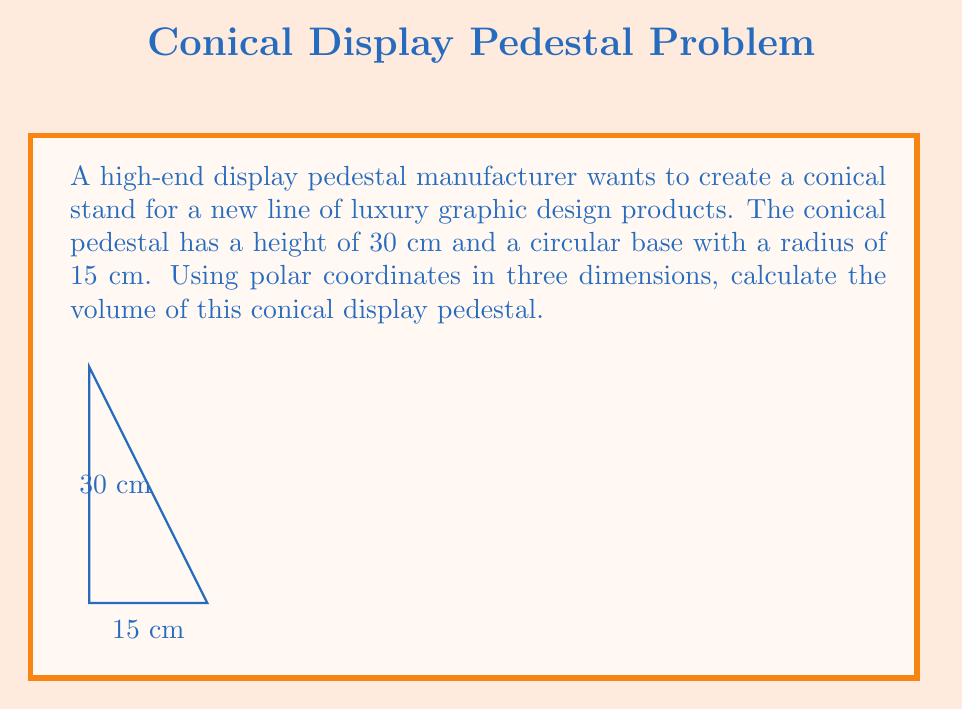Show me your answer to this math problem. To compute the volume of the conical display pedestal using polar coordinates in three dimensions, we'll follow these steps:

1) In polar coordinates, we can represent the cone as:
   $$r = R\frac{h-z}{h}$$
   where $R$ is the base radius, $h$ is the height, and $z$ is the vertical coordinate.

2) The volume formula in polar coordinates is:
   $$V = \int_0^h \int_0^{2\pi} \int_0^{r(z)} \rho \, d\rho \, d\theta \, dz$$

3) Substituting our cone equation:
   $$V = \int_0^h \int_0^{2\pi} \int_0^{R\frac{h-z}{h}} \rho \, d\rho \, d\theta \, dz$$

4) Evaluate the innermost integral:
   $$V = \int_0^h \int_0^{2\pi} \left[\frac{1}{2}\rho^2\right]_0^{R\frac{h-z}{h}} \, d\theta \, dz$$
   $$V = \int_0^h \int_0^{2\pi} \frac{1}{2}\left(R\frac{h-z}{h}\right)^2 \, d\theta \, dz$$

5) Evaluate the $\theta$ integral:
   $$V = \int_0^h 2\pi \cdot \frac{1}{2}\left(R\frac{h-z}{h}\right)^2 \, dz$$
   $$V = \pi R^2 \int_0^h \left(\frac{h-z}{h}\right)^2 \, dz$$

6) Evaluate the final integral:
   $$V = \pi R^2 \left[-\frac{1}{3h^2}(h-z)^3\right]_0^h$$
   $$V = \pi R^2 \left(-\frac{1}{3h^2}(0)^3 + \frac{1}{3h^2}h^3\right)$$
   $$V = \frac{1}{3}\pi R^2 h$$

7) Now, substitute the given values: $R = 15$ cm, $h = 30$ cm
   $$V = \frac{1}{3} \pi (15\text{ cm})^2 (30\text{ cm})$$
   $$V = 2250\pi \text{ cm}^3$$

8) Calculate the final result:
   $$V \approx 7068.58 \text{ cm}^3$$
Answer: $7068.58 \text{ cm}^3$ 